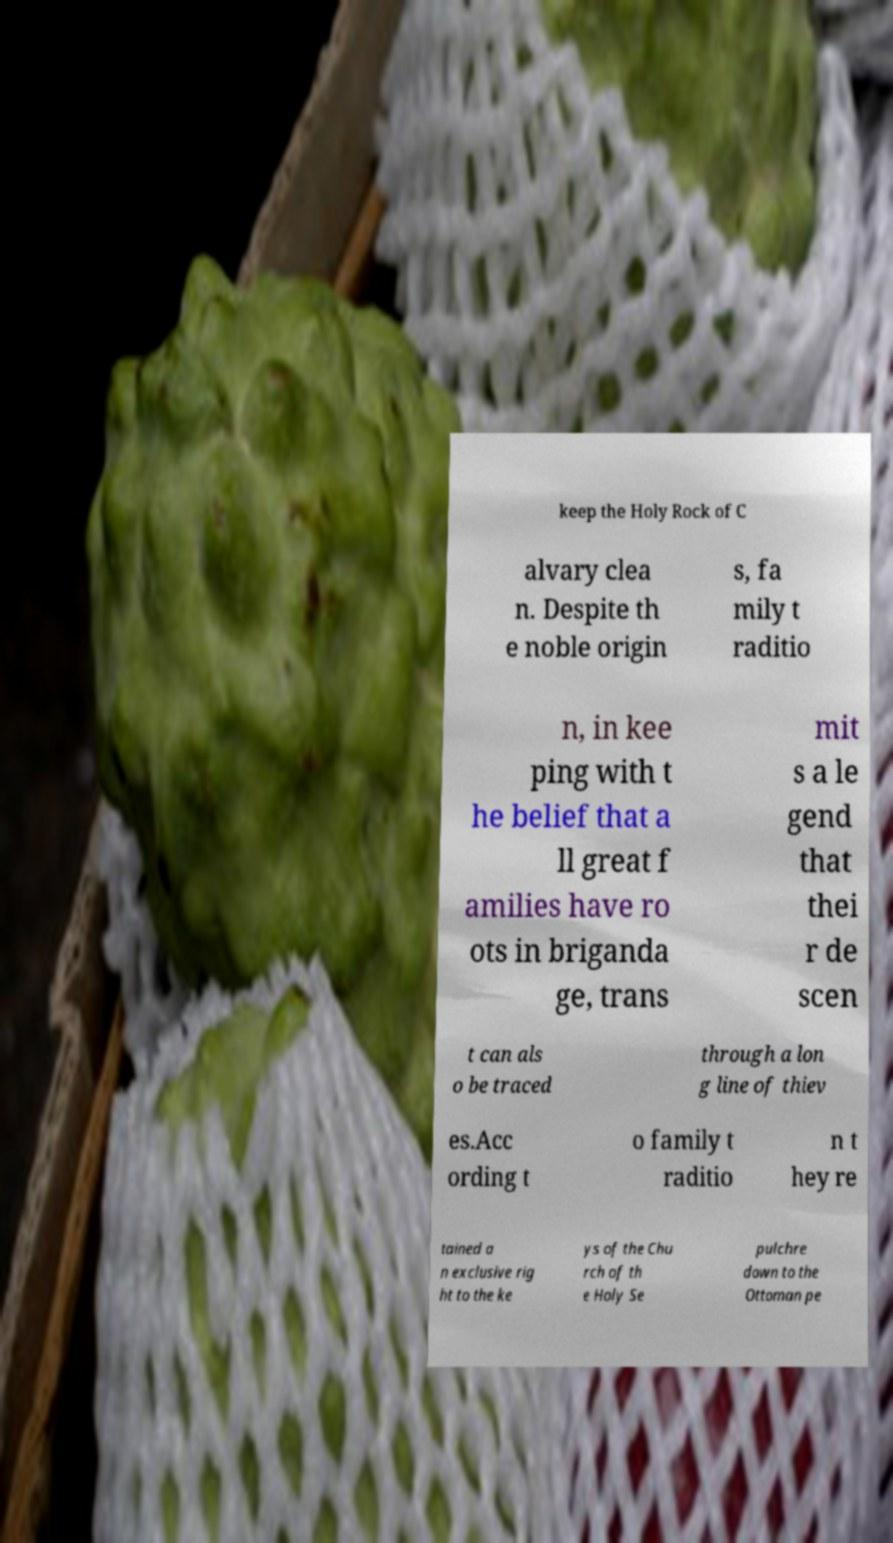Could you extract and type out the text from this image? keep the Holy Rock of C alvary clea n. Despite th e noble origin s, fa mily t raditio n, in kee ping with t he belief that a ll great f amilies have ro ots in briganda ge, trans mit s a le gend that thei r de scen t can als o be traced through a lon g line of thiev es.Acc ording t o family t raditio n t hey re tained a n exclusive rig ht to the ke ys of the Chu rch of th e Holy Se pulchre down to the Ottoman pe 